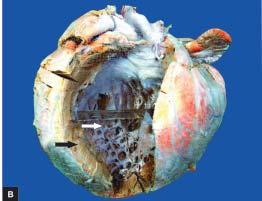s periphery thickened hypertrophy with dilatation?
Answer the question using a single word or phrase. No 